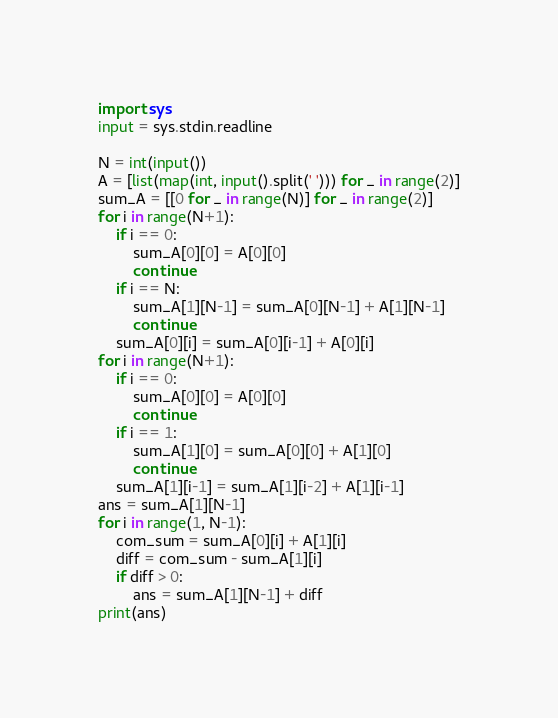Convert code to text. <code><loc_0><loc_0><loc_500><loc_500><_Python_>import sys
input = sys.stdin.readline

N = int(input())
A = [list(map(int, input().split(' '))) for _ in range(2)]
sum_A = [[0 for _ in range(N)] for _ in range(2)]
for i in range(N+1):
    if i == 0:
        sum_A[0][0] = A[0][0]
        continue
    if i == N:
        sum_A[1][N-1] = sum_A[0][N-1] + A[1][N-1]
        continue
    sum_A[0][i] = sum_A[0][i-1] + A[0][i]
for i in range(N+1):
    if i == 0:
        sum_A[0][0] = A[0][0]
        continue
    if i == 1:
        sum_A[1][0] = sum_A[0][0] + A[1][0]
        continue
    sum_A[1][i-1] = sum_A[1][i-2] + A[1][i-1]
ans = sum_A[1][N-1]
for i in range(1, N-1):
    com_sum = sum_A[0][i] + A[1][i]
    diff = com_sum - sum_A[1][i]
    if diff > 0:
        ans = sum_A[1][N-1] + diff
print(ans)</code> 